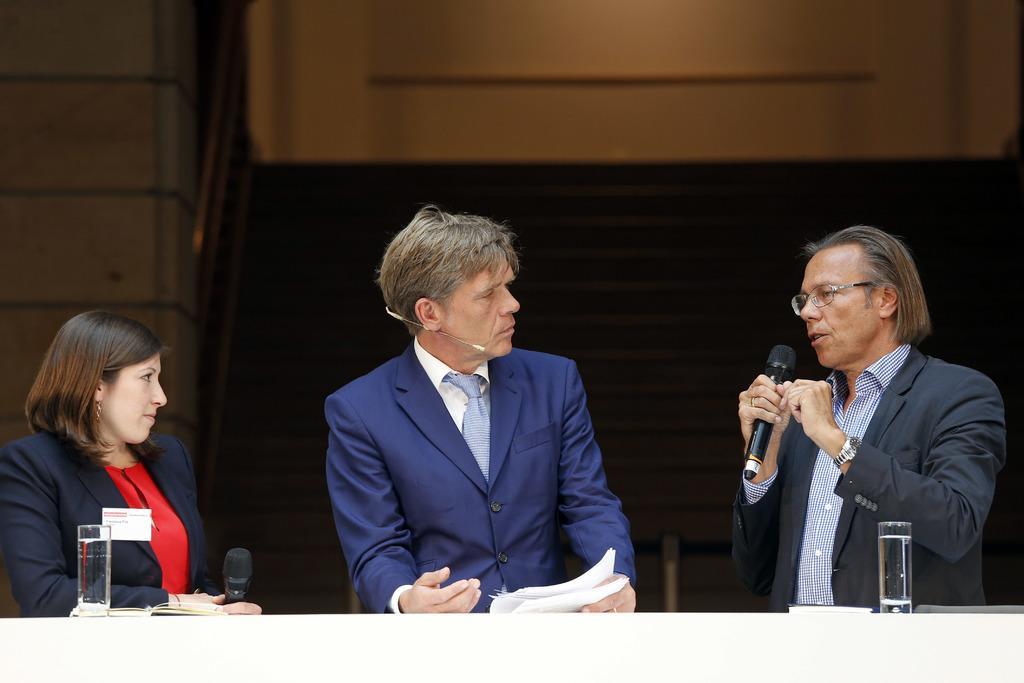How would you summarize this image in a sentence or two? At the right side of the picture we can see one man holding a mike in his hand and talking. this is a water glass. We can see this man wearing blue colour blazer, holding papers in his hand. At the left side of the picture we can see a woman holding a mike in her hand. This is a water glass. 